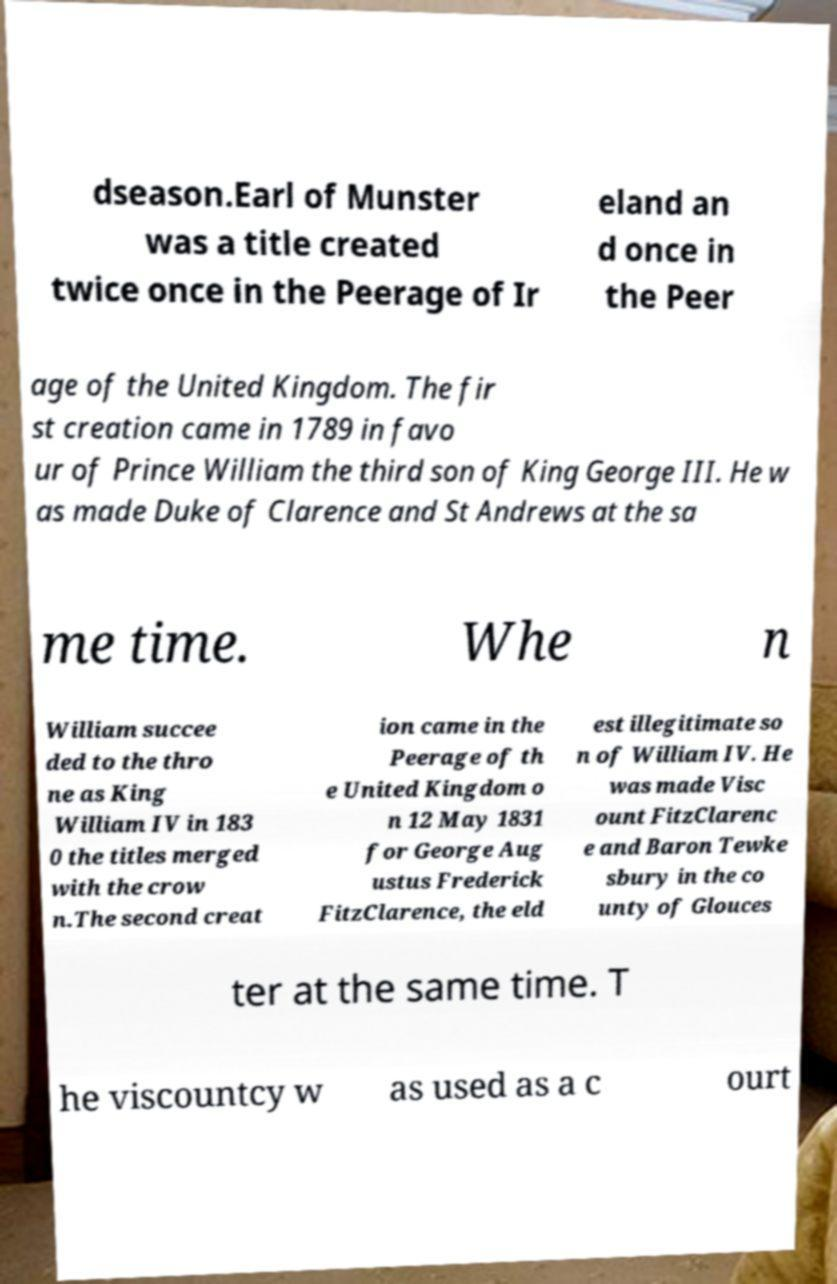There's text embedded in this image that I need extracted. Can you transcribe it verbatim? dseason.Earl of Munster was a title created twice once in the Peerage of Ir eland an d once in the Peer age of the United Kingdom. The fir st creation came in 1789 in favo ur of Prince William the third son of King George III. He w as made Duke of Clarence and St Andrews at the sa me time. Whe n William succee ded to the thro ne as King William IV in 183 0 the titles merged with the crow n.The second creat ion came in the Peerage of th e United Kingdom o n 12 May 1831 for George Aug ustus Frederick FitzClarence, the eld est illegitimate so n of William IV. He was made Visc ount FitzClarenc e and Baron Tewke sbury in the co unty of Glouces ter at the same time. T he viscountcy w as used as a c ourt 